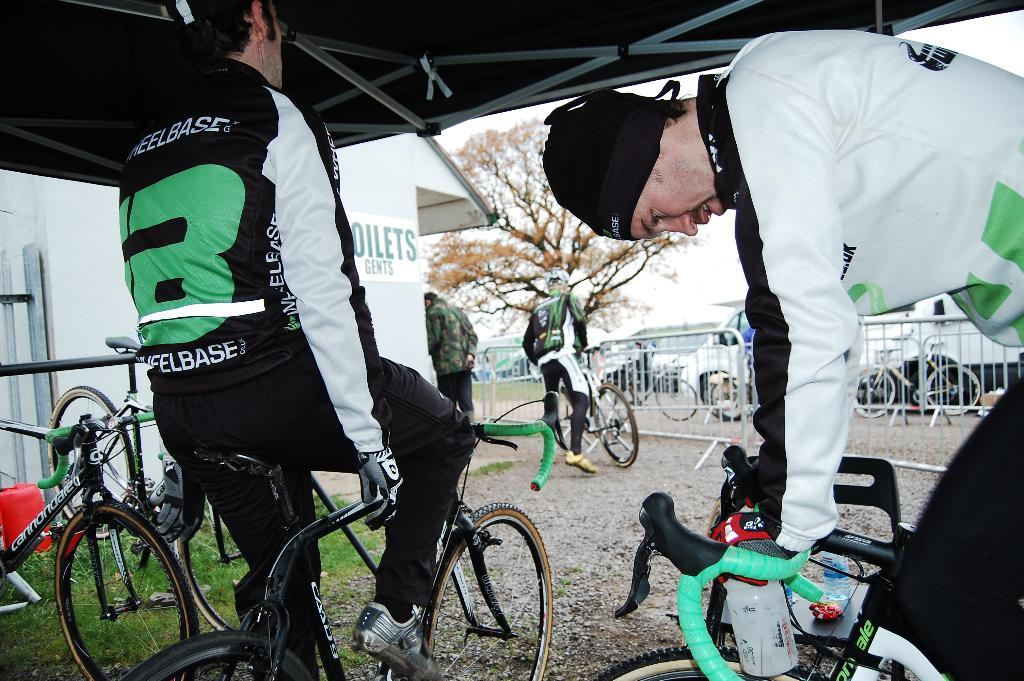What are the people in the image doing? The people in the image are sitting on bicycles. Is there anyone in the image not riding a bicycle? Yes, there is a person holding a bicycle in the image. What can be seen in the background of the image? Trees are visible in the image. What type of yak can be seen grazing in the image? There is no yak present in the image; it features people sitting on bicycles and trees in the background. How many months are depicted in the image? The image does not depict any months; it is a photograph of people and trees. 